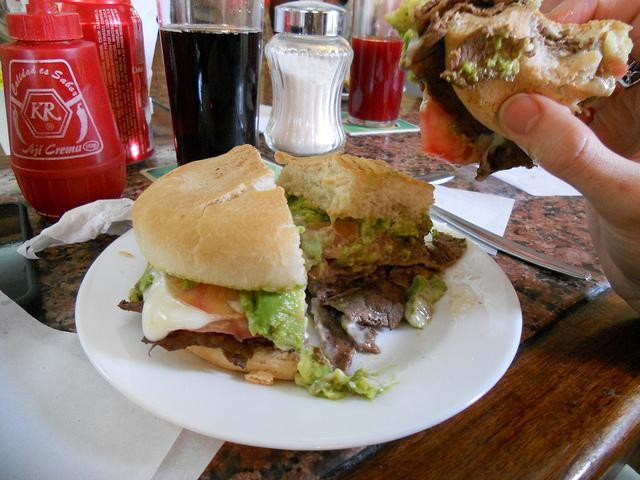What is she doing with the sandwich? Please explain your reasoning. eating it. The meal is brought  at the table to the customer to be feed. 